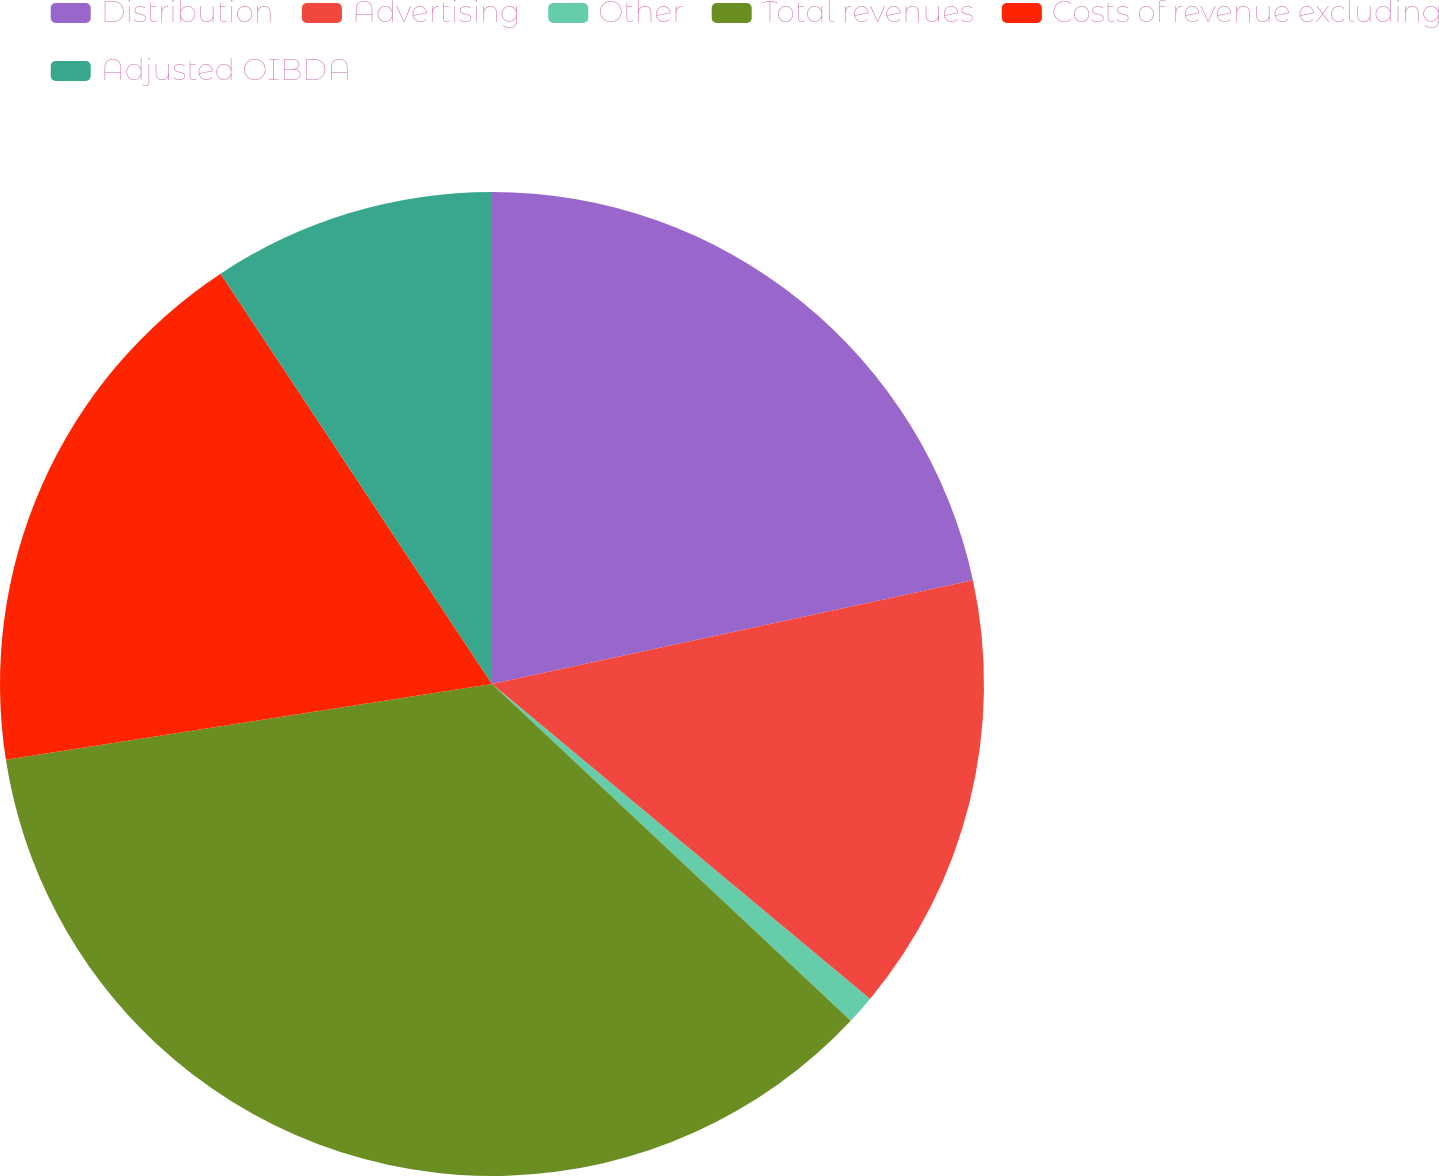Convert chart. <chart><loc_0><loc_0><loc_500><loc_500><pie_chart><fcel>Distribution<fcel>Advertising<fcel>Other<fcel>Total revenues<fcel>Costs of revenue excluding<fcel>Adjusted OIBDA<nl><fcel>21.62%<fcel>14.43%<fcel>0.94%<fcel>35.54%<fcel>18.16%<fcel>9.3%<nl></chart> 